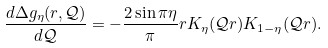<formula> <loc_0><loc_0><loc_500><loc_500>\frac { d \Delta g _ { \eta } ( r , \mathcal { Q } ) } { d \mathcal { Q } } = - \frac { 2 \sin \pi \eta } { \pi } r K _ { \eta } ( \mathcal { Q } r ) K _ { 1 - \eta } ( \mathcal { Q } r ) .</formula> 